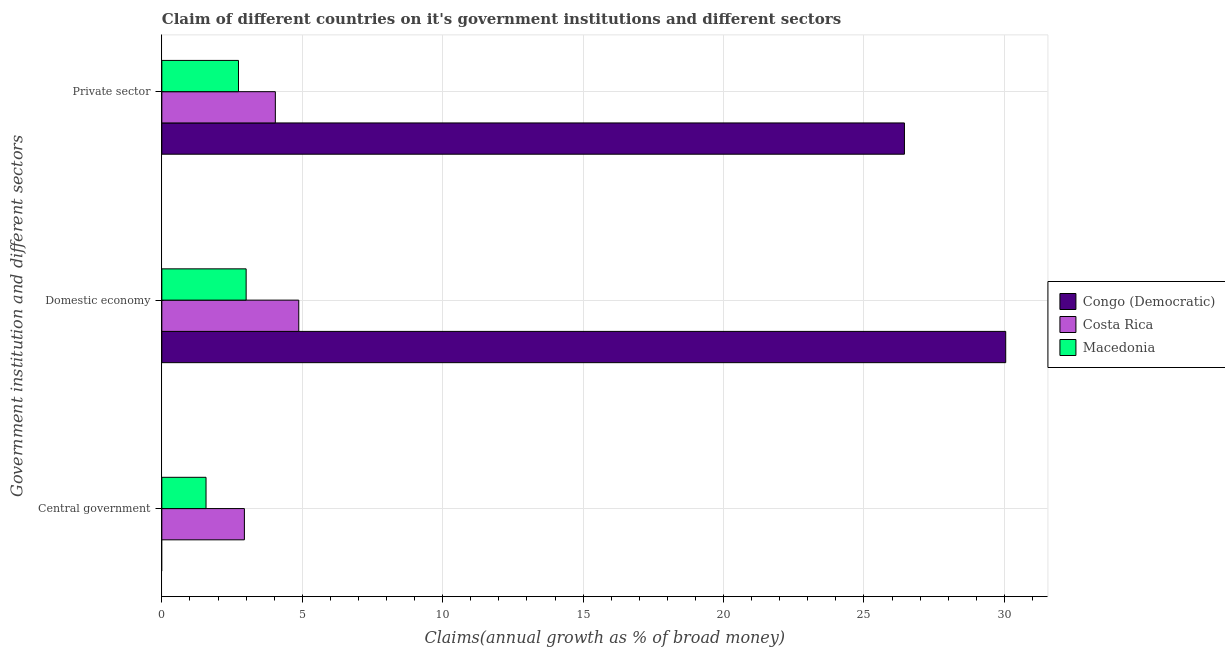How many different coloured bars are there?
Your answer should be very brief. 3. How many groups of bars are there?
Ensure brevity in your answer.  3. Are the number of bars on each tick of the Y-axis equal?
Your answer should be very brief. No. How many bars are there on the 2nd tick from the top?
Make the answer very short. 3. What is the label of the 3rd group of bars from the top?
Ensure brevity in your answer.  Central government. What is the percentage of claim on the central government in Costa Rica?
Offer a terse response. 2.94. Across all countries, what is the maximum percentage of claim on the private sector?
Your answer should be compact. 26.44. Across all countries, what is the minimum percentage of claim on the domestic economy?
Give a very brief answer. 3. What is the total percentage of claim on the private sector in the graph?
Provide a short and direct response. 33.21. What is the difference between the percentage of claim on the central government in Costa Rica and that in Macedonia?
Keep it short and to the point. 1.37. What is the difference between the percentage of claim on the domestic economy in Congo (Democratic) and the percentage of claim on the central government in Costa Rica?
Give a very brief answer. 27.11. What is the average percentage of claim on the domestic economy per country?
Offer a terse response. 12.64. What is the difference between the percentage of claim on the domestic economy and percentage of claim on the central government in Costa Rica?
Provide a succinct answer. 1.94. In how many countries, is the percentage of claim on the central government greater than 12 %?
Offer a very short reply. 0. What is the ratio of the percentage of claim on the central government in Macedonia to that in Costa Rica?
Make the answer very short. 0.54. Is the percentage of claim on the central government in Macedonia less than that in Costa Rica?
Ensure brevity in your answer.  Yes. Is the difference between the percentage of claim on the private sector in Macedonia and Costa Rica greater than the difference between the percentage of claim on the domestic economy in Macedonia and Costa Rica?
Your response must be concise. Yes. What is the difference between the highest and the second highest percentage of claim on the domestic economy?
Your answer should be very brief. 25.17. What is the difference between the highest and the lowest percentage of claim on the central government?
Keep it short and to the point. 2.94. Is the sum of the percentage of claim on the private sector in Costa Rica and Macedonia greater than the maximum percentage of claim on the domestic economy across all countries?
Your answer should be compact. No. How many bars are there?
Provide a short and direct response. 8. Are the values on the major ticks of X-axis written in scientific E-notation?
Your answer should be compact. No. Does the graph contain grids?
Offer a very short reply. Yes. Where does the legend appear in the graph?
Ensure brevity in your answer.  Center right. How many legend labels are there?
Your response must be concise. 3. How are the legend labels stacked?
Provide a succinct answer. Vertical. What is the title of the graph?
Offer a very short reply. Claim of different countries on it's government institutions and different sectors. Does "Haiti" appear as one of the legend labels in the graph?
Your answer should be compact. No. What is the label or title of the X-axis?
Your answer should be very brief. Claims(annual growth as % of broad money). What is the label or title of the Y-axis?
Give a very brief answer. Government institution and different sectors. What is the Claims(annual growth as % of broad money) of Costa Rica in Central government?
Give a very brief answer. 2.94. What is the Claims(annual growth as % of broad money) of Macedonia in Central government?
Provide a succinct answer. 1.57. What is the Claims(annual growth as % of broad money) in Congo (Democratic) in Domestic economy?
Give a very brief answer. 30.05. What is the Claims(annual growth as % of broad money) in Costa Rica in Domestic economy?
Offer a terse response. 4.88. What is the Claims(annual growth as % of broad money) of Macedonia in Domestic economy?
Ensure brevity in your answer.  3. What is the Claims(annual growth as % of broad money) in Congo (Democratic) in Private sector?
Provide a succinct answer. 26.44. What is the Claims(annual growth as % of broad money) in Costa Rica in Private sector?
Provide a succinct answer. 4.04. What is the Claims(annual growth as % of broad money) of Macedonia in Private sector?
Your answer should be compact. 2.73. Across all Government institution and different sectors, what is the maximum Claims(annual growth as % of broad money) of Congo (Democratic)?
Your response must be concise. 30.05. Across all Government institution and different sectors, what is the maximum Claims(annual growth as % of broad money) in Costa Rica?
Offer a very short reply. 4.88. Across all Government institution and different sectors, what is the maximum Claims(annual growth as % of broad money) of Macedonia?
Make the answer very short. 3. Across all Government institution and different sectors, what is the minimum Claims(annual growth as % of broad money) in Congo (Democratic)?
Offer a very short reply. 0. Across all Government institution and different sectors, what is the minimum Claims(annual growth as % of broad money) of Costa Rica?
Offer a terse response. 2.94. Across all Government institution and different sectors, what is the minimum Claims(annual growth as % of broad money) of Macedonia?
Make the answer very short. 1.57. What is the total Claims(annual growth as % of broad money) of Congo (Democratic) in the graph?
Provide a short and direct response. 56.49. What is the total Claims(annual growth as % of broad money) in Costa Rica in the graph?
Your response must be concise. 11.86. What is the total Claims(annual growth as % of broad money) in Macedonia in the graph?
Offer a very short reply. 7.31. What is the difference between the Claims(annual growth as % of broad money) of Costa Rica in Central government and that in Domestic economy?
Your response must be concise. -1.94. What is the difference between the Claims(annual growth as % of broad money) in Macedonia in Central government and that in Domestic economy?
Provide a succinct answer. -1.43. What is the difference between the Claims(annual growth as % of broad money) of Costa Rica in Central government and that in Private sector?
Your answer should be compact. -1.1. What is the difference between the Claims(annual growth as % of broad money) in Macedonia in Central government and that in Private sector?
Your answer should be compact. -1.16. What is the difference between the Claims(annual growth as % of broad money) in Congo (Democratic) in Domestic economy and that in Private sector?
Give a very brief answer. 3.61. What is the difference between the Claims(annual growth as % of broad money) in Costa Rica in Domestic economy and that in Private sector?
Your answer should be very brief. 0.83. What is the difference between the Claims(annual growth as % of broad money) in Macedonia in Domestic economy and that in Private sector?
Give a very brief answer. 0.27. What is the difference between the Claims(annual growth as % of broad money) of Costa Rica in Central government and the Claims(annual growth as % of broad money) of Macedonia in Domestic economy?
Offer a terse response. -0.06. What is the difference between the Claims(annual growth as % of broad money) in Costa Rica in Central government and the Claims(annual growth as % of broad money) in Macedonia in Private sector?
Provide a succinct answer. 0.21. What is the difference between the Claims(annual growth as % of broad money) in Congo (Democratic) in Domestic economy and the Claims(annual growth as % of broad money) in Costa Rica in Private sector?
Make the answer very short. 26.01. What is the difference between the Claims(annual growth as % of broad money) of Congo (Democratic) in Domestic economy and the Claims(annual growth as % of broad money) of Macedonia in Private sector?
Provide a succinct answer. 27.32. What is the difference between the Claims(annual growth as % of broad money) of Costa Rica in Domestic economy and the Claims(annual growth as % of broad money) of Macedonia in Private sector?
Offer a very short reply. 2.15. What is the average Claims(annual growth as % of broad money) of Congo (Democratic) per Government institution and different sectors?
Give a very brief answer. 18.83. What is the average Claims(annual growth as % of broad money) of Costa Rica per Government institution and different sectors?
Provide a short and direct response. 3.95. What is the average Claims(annual growth as % of broad money) of Macedonia per Government institution and different sectors?
Your answer should be very brief. 2.44. What is the difference between the Claims(annual growth as % of broad money) of Costa Rica and Claims(annual growth as % of broad money) of Macedonia in Central government?
Provide a short and direct response. 1.37. What is the difference between the Claims(annual growth as % of broad money) in Congo (Democratic) and Claims(annual growth as % of broad money) in Costa Rica in Domestic economy?
Offer a terse response. 25.17. What is the difference between the Claims(annual growth as % of broad money) in Congo (Democratic) and Claims(annual growth as % of broad money) in Macedonia in Domestic economy?
Provide a succinct answer. 27.05. What is the difference between the Claims(annual growth as % of broad money) of Costa Rica and Claims(annual growth as % of broad money) of Macedonia in Domestic economy?
Offer a very short reply. 1.87. What is the difference between the Claims(annual growth as % of broad money) in Congo (Democratic) and Claims(annual growth as % of broad money) in Costa Rica in Private sector?
Your answer should be compact. 22.4. What is the difference between the Claims(annual growth as % of broad money) in Congo (Democratic) and Claims(annual growth as % of broad money) in Macedonia in Private sector?
Your answer should be compact. 23.71. What is the difference between the Claims(annual growth as % of broad money) in Costa Rica and Claims(annual growth as % of broad money) in Macedonia in Private sector?
Your response must be concise. 1.31. What is the ratio of the Claims(annual growth as % of broad money) of Costa Rica in Central government to that in Domestic economy?
Your answer should be very brief. 0.6. What is the ratio of the Claims(annual growth as % of broad money) of Macedonia in Central government to that in Domestic economy?
Ensure brevity in your answer.  0.52. What is the ratio of the Claims(annual growth as % of broad money) of Costa Rica in Central government to that in Private sector?
Provide a succinct answer. 0.73. What is the ratio of the Claims(annual growth as % of broad money) of Macedonia in Central government to that in Private sector?
Offer a very short reply. 0.58. What is the ratio of the Claims(annual growth as % of broad money) in Congo (Democratic) in Domestic economy to that in Private sector?
Provide a short and direct response. 1.14. What is the ratio of the Claims(annual growth as % of broad money) in Costa Rica in Domestic economy to that in Private sector?
Offer a very short reply. 1.21. What is the ratio of the Claims(annual growth as % of broad money) of Macedonia in Domestic economy to that in Private sector?
Provide a succinct answer. 1.1. What is the difference between the highest and the second highest Claims(annual growth as % of broad money) in Costa Rica?
Provide a succinct answer. 0.83. What is the difference between the highest and the second highest Claims(annual growth as % of broad money) in Macedonia?
Your answer should be very brief. 0.27. What is the difference between the highest and the lowest Claims(annual growth as % of broad money) of Congo (Democratic)?
Your answer should be compact. 30.05. What is the difference between the highest and the lowest Claims(annual growth as % of broad money) of Costa Rica?
Your answer should be very brief. 1.94. What is the difference between the highest and the lowest Claims(annual growth as % of broad money) of Macedonia?
Your answer should be compact. 1.43. 